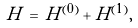<formula> <loc_0><loc_0><loc_500><loc_500>H \, = \, H ^ { ( 0 ) } + H ^ { ( 1 ) } ,</formula> 